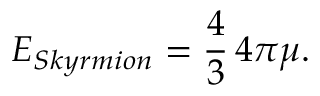Convert formula to latex. <formula><loc_0><loc_0><loc_500><loc_500>E _ { S k y r m i o n } = { \frac { 4 } { 3 } } \, 4 \pi \mu .</formula> 